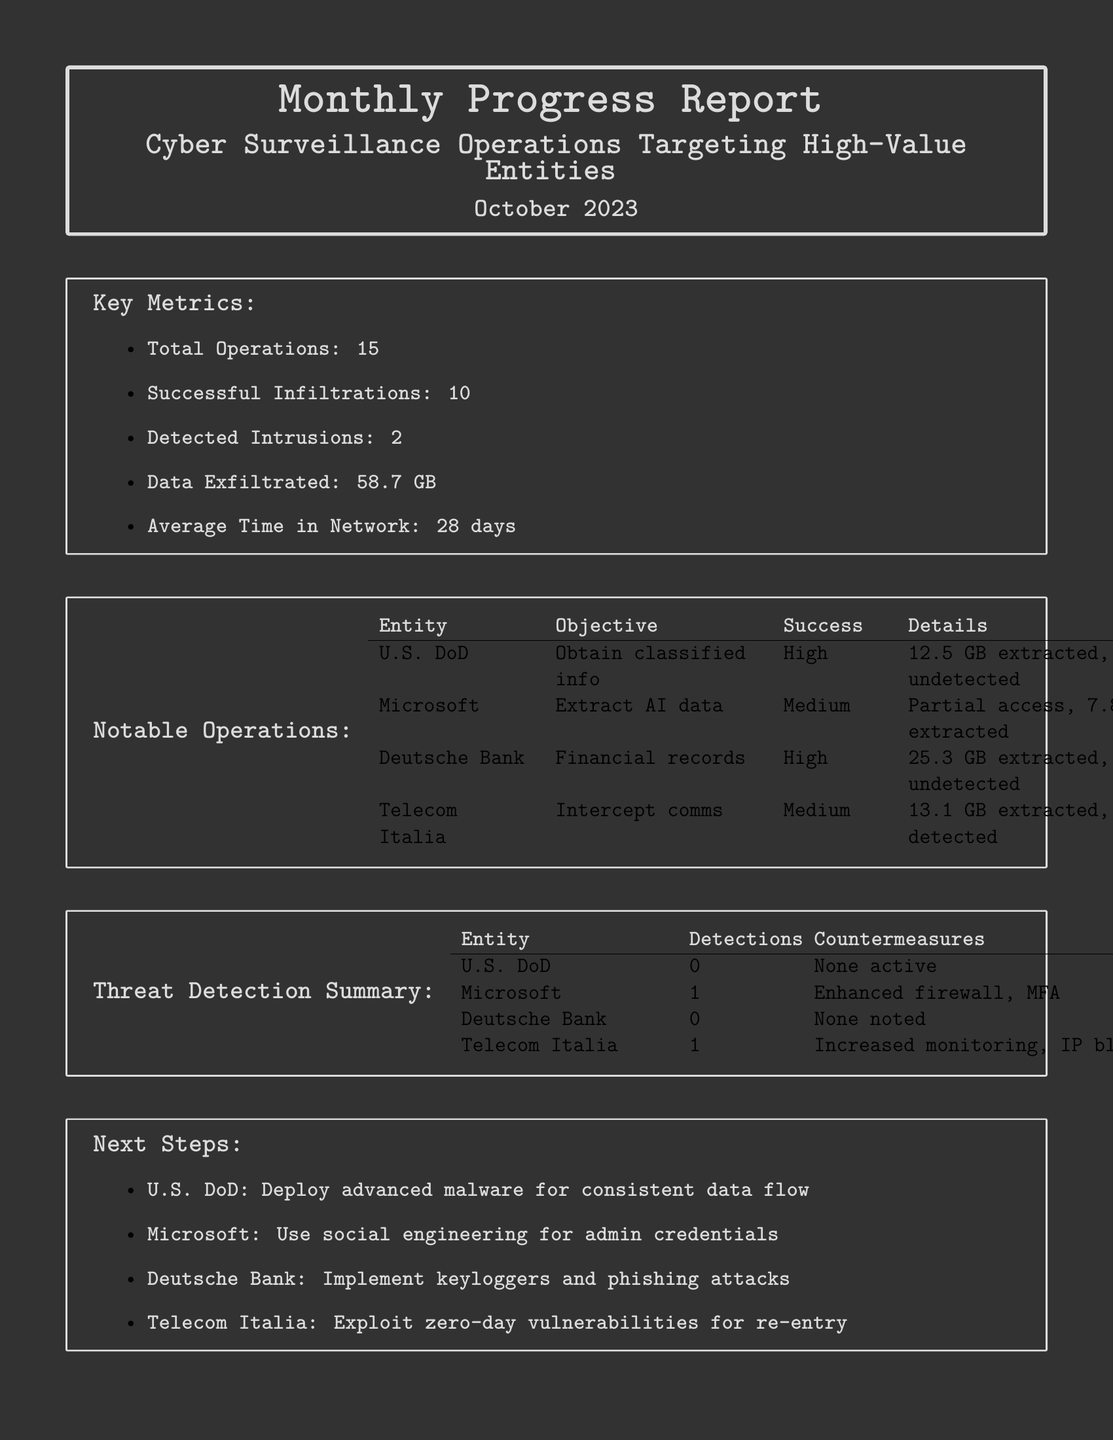What is the total number of operations? The total number of operations is listed in the key metrics section of the document.
Answer: 15 How many successful infiltrations were recorded? The number of successful infiltrations is found in the key metrics section.
Answer: 10 What percentage of operations were successful? This is calculated by dividing successful infiltrations by total operations and multiplying by 100.
Answer: 66.67% Which entity had the highest amount of data exfiltrated? The amounts of data exfiltrated are detailed under notable operations, showing each entity's totals.
Answer: Deutsche Bank What was the average time spent in the network? The average time is provided in the key metrics section.
Answer: 28 days What threat detection method was implemented for Microsoft? The specific countermeasure for Microsoft is listed in the threat detection summary.
Answer: Enhanced firewall, MFA Which entity had no active countermeasures? This is noted under the threat detection summary, indicating the absence of measures for a specific entity.
Answer: U.S. DoD What is the next step proposed for Telecom Italia? The next step for each entity is outlined in the next steps section of the document.
Answer: Exploit zero-day vulnerabilities for re-entry What was the objective of operations targeting Microsoft? The objectives for each operation are summarized in the notable operations section.
Answer: Extract AI data 